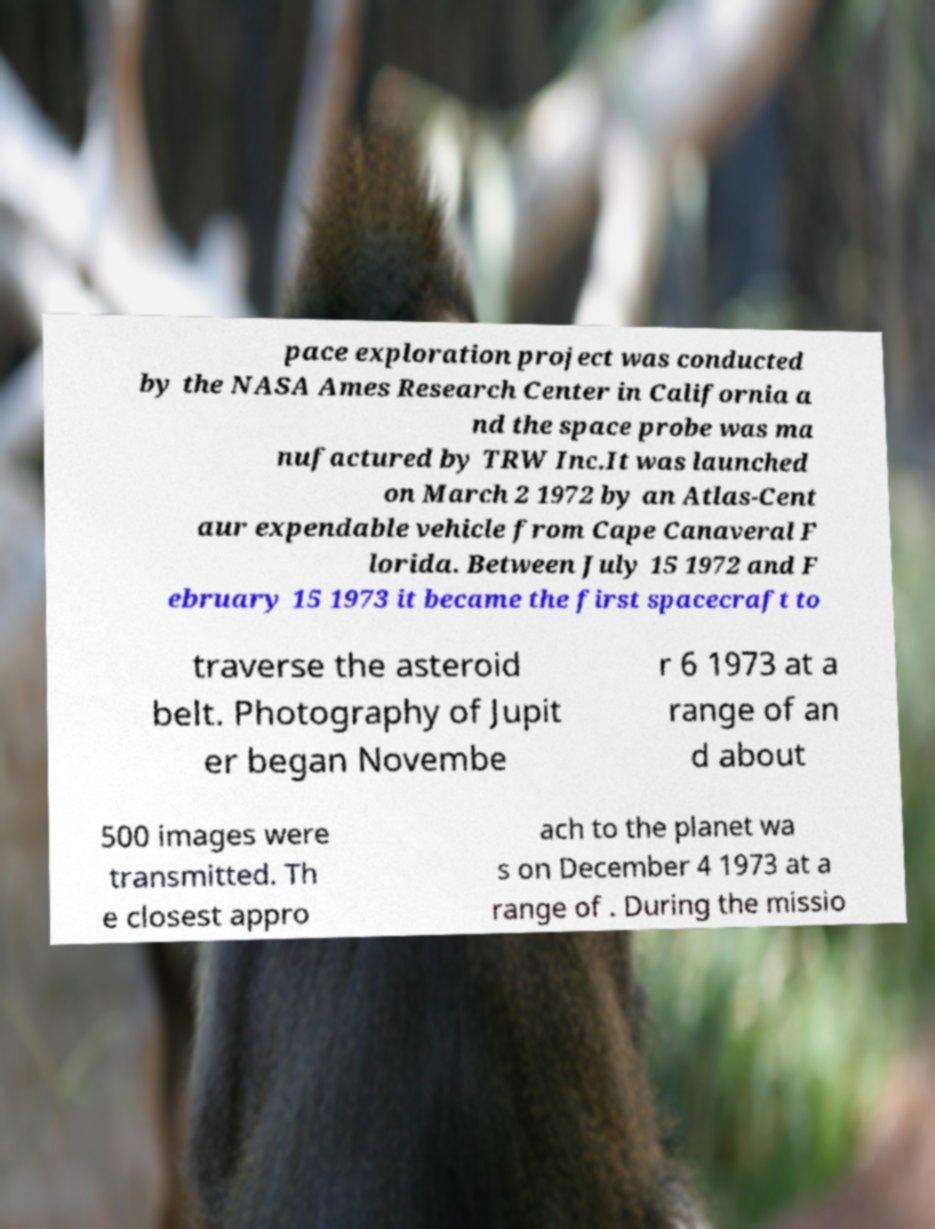Please identify and transcribe the text found in this image. pace exploration project was conducted by the NASA Ames Research Center in California a nd the space probe was ma nufactured by TRW Inc.It was launched on March 2 1972 by an Atlas-Cent aur expendable vehicle from Cape Canaveral F lorida. Between July 15 1972 and F ebruary 15 1973 it became the first spacecraft to traverse the asteroid belt. Photography of Jupit er began Novembe r 6 1973 at a range of an d about 500 images were transmitted. Th e closest appro ach to the planet wa s on December 4 1973 at a range of . During the missio 